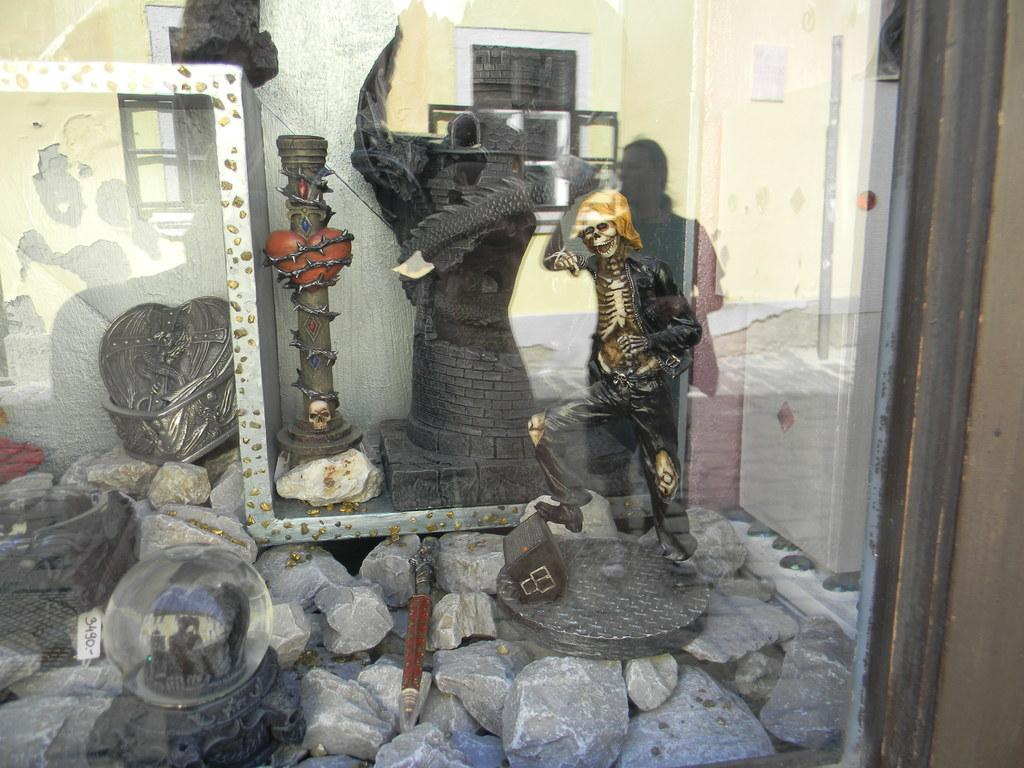What is in the image that can hold a liquid? There is a glass in the image. What can be seen through the glass? Statues are visible through the glass. What material is present in the image? Stone is present in the image. What objects are visible in the image? There are objects visible in the image, including statues and a glass. What can be seen in the reflection in the glass? A person's reflection is visible in the glass, along with a wall and windows. What type of mist can be seen surrounding the statues in the image? There is no mist present in the image; the statues are visible through the glass. 